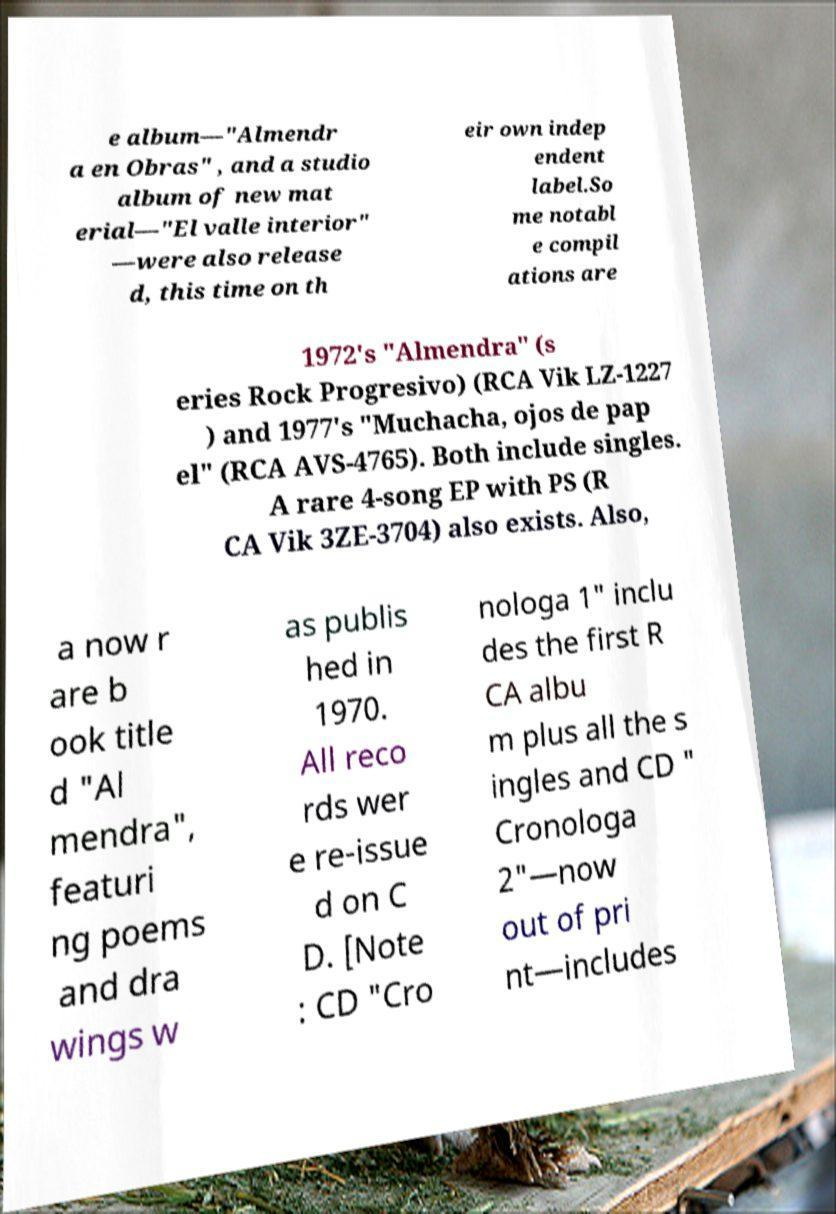Could you assist in decoding the text presented in this image and type it out clearly? e album—"Almendr a en Obras" , and a studio album of new mat erial—"El valle interior" —were also release d, this time on th eir own indep endent label.So me notabl e compil ations are 1972's "Almendra" (s eries Rock Progresivo) (RCA Vik LZ-1227 ) and 1977's "Muchacha, ojos de pap el" (RCA AVS-4765). Both include singles. A rare 4-song EP with PS (R CA Vik 3ZE-3704) also exists. Also, a now r are b ook title d "Al mendra", featuri ng poems and dra wings w as publis hed in 1970. All reco rds wer e re-issue d on C D. [Note : CD "Cro nologa 1" inclu des the first R CA albu m plus all the s ingles and CD " Cronologa 2"—now out of pri nt—includes 